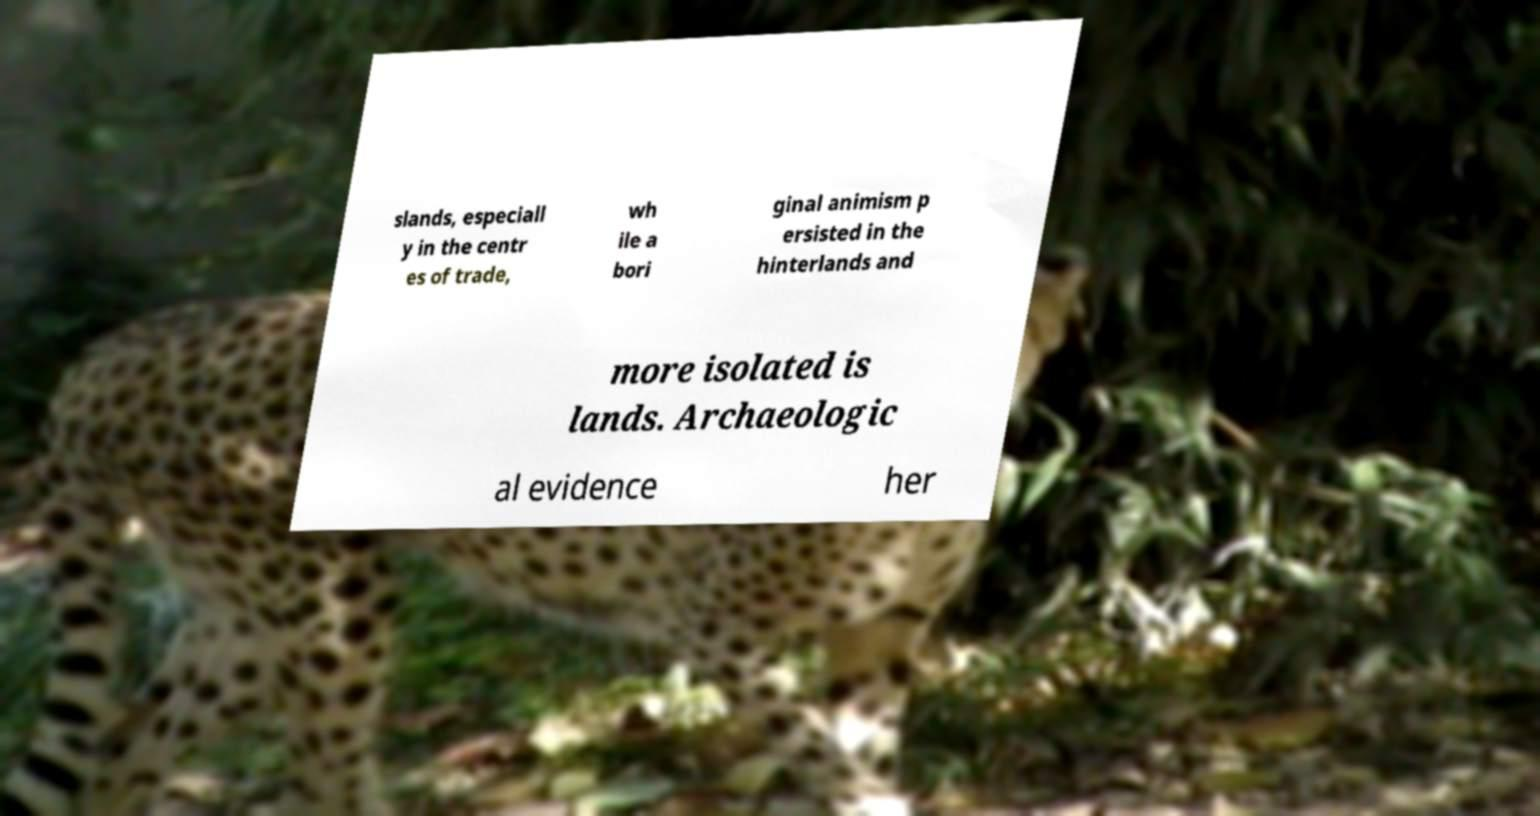Please read and relay the text visible in this image. What does it say? slands, especiall y in the centr es of trade, wh ile a bori ginal animism p ersisted in the hinterlands and more isolated is lands. Archaeologic al evidence her 